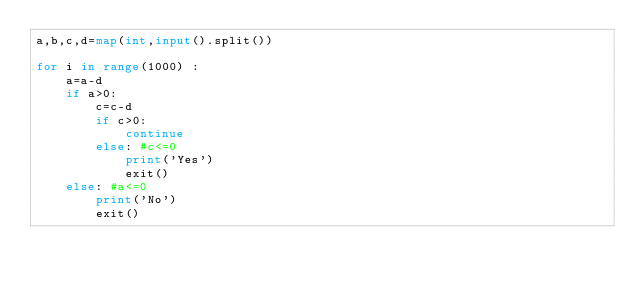Convert code to text. <code><loc_0><loc_0><loc_500><loc_500><_Python_>a,b,c,d=map(int,input().split())

for i in range(1000) :
    a=a-d
    if a>0:
        c=c-d
        if c>0:
            continue
        else: #c<=0
            print('Yes')
            exit()
    else: #a<=0
        print('No')
        exit()</code> 